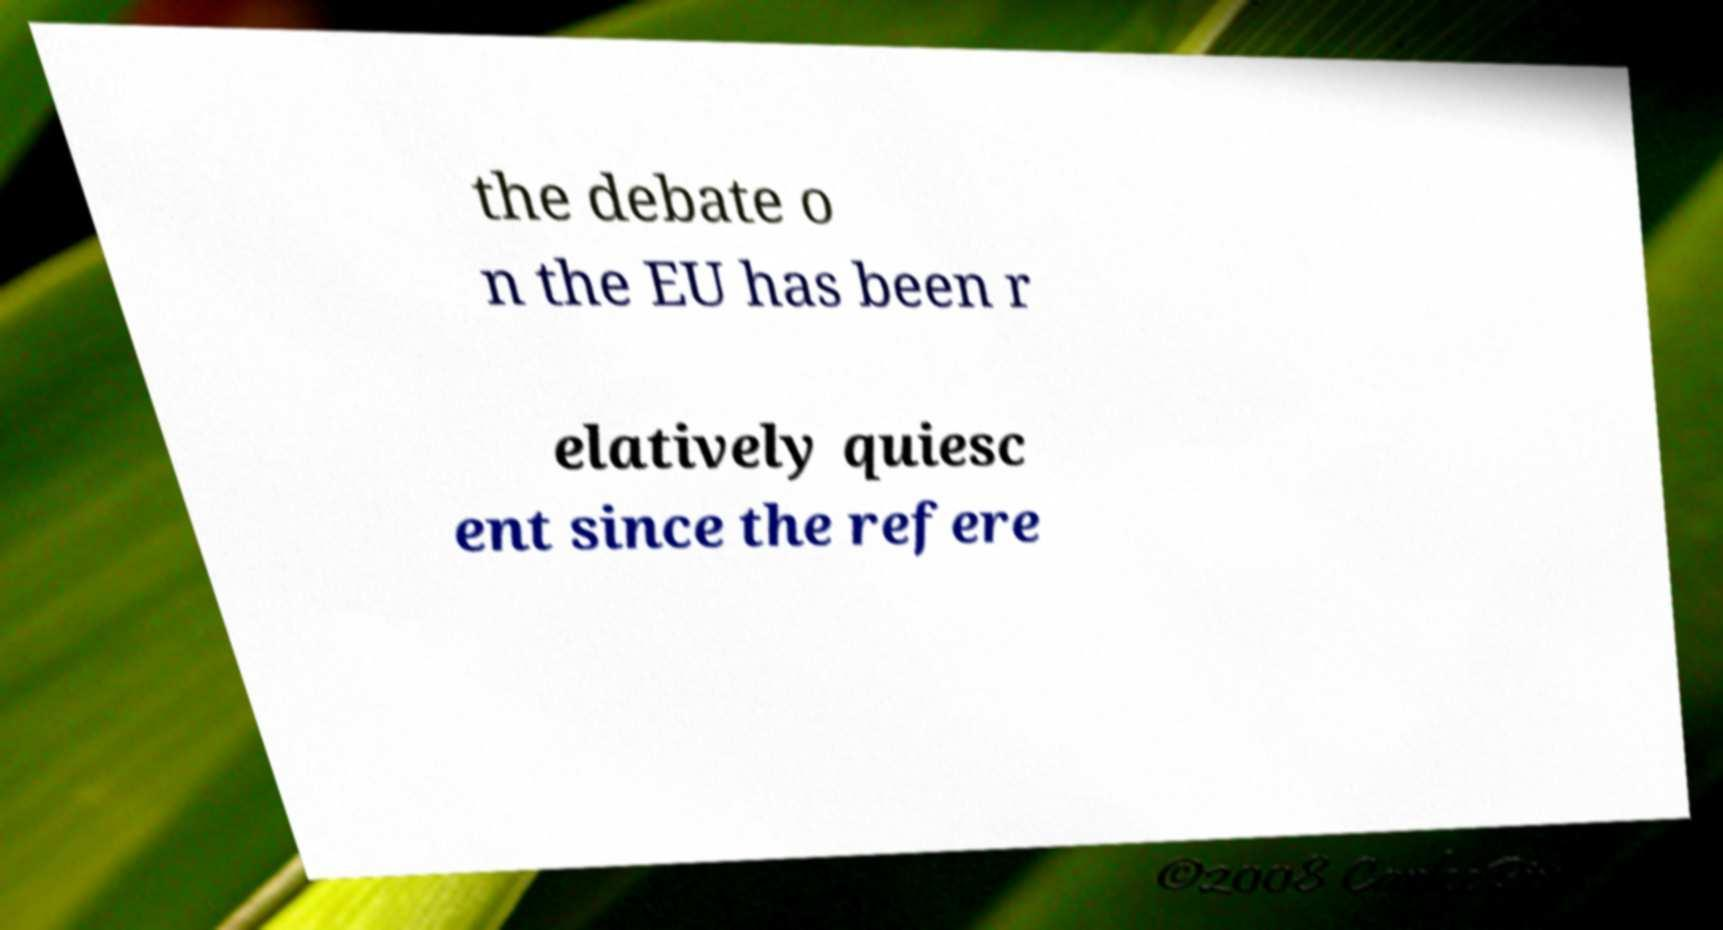Can you read and provide the text displayed in the image?This photo seems to have some interesting text. Can you extract and type it out for me? the debate o n the EU has been r elatively quiesc ent since the refere 